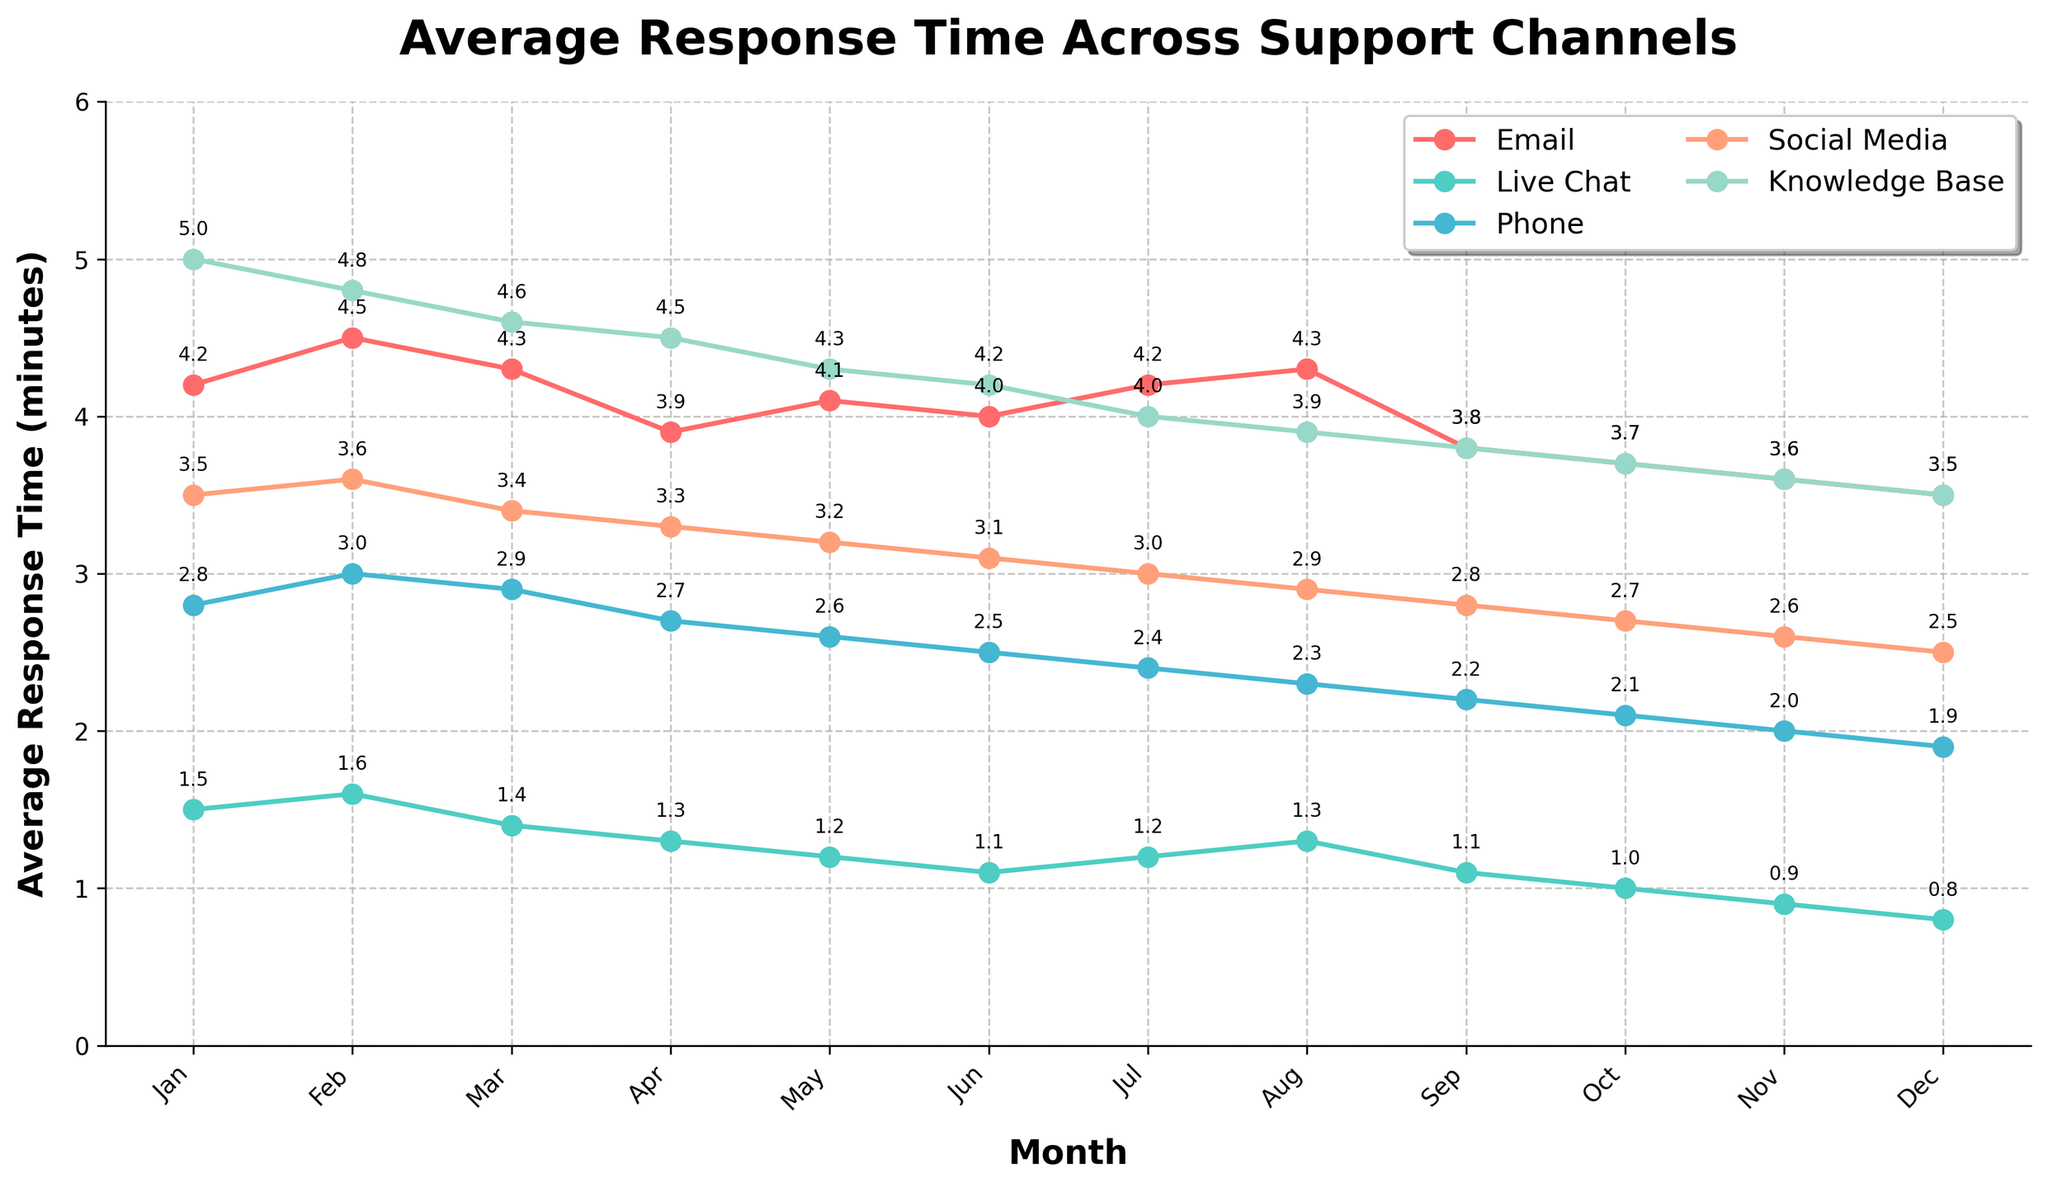What's the channel with the fastest response time in December? Looking at the chart, the line representing Live Chat has the lowest point in December.
Answer: Live Chat Which month shows the highest response time for the Email channel? The chart shows the highest point for the Email line in February.
Answer: February What is the trend in the Phone channel’s response time from January to December? The chart shows a steadily decreasing line for the Phone channel from January to December.
Answer: Decreasing Compare the average response times between Social Media and Knowledge Base in June. Which one is higher? In June, the chart shows that Social Media has an average response time lower than Knowledge Base.
Answer: Knowledge Base What's the difference between the response times of Live Chat and Phone in October? In October, the chart shows that Live Chat has a response time of 1.0 mins and Phone has 2.1 mins. The difference is 2.1 - 1.0 = 1.1 mins.
Answer: 1.1 mins What is the most significant visual change in the Knowledge Base channel over the year? The chart shows a steep decline from January to December for the Knowledge Base channel.
Answer: Steep decline Which channel shows the most consistent average response time throughout the year? From the chart, Live Chat has the most consistent average response time with a smooth downward trend and small fluctuations.
Answer: Live Chat What is the average response time for the Email channel in the first half of the year (Jan-Jun)? The response times for Email from Jan to Jun are 4.2, 4.5, 4.3, 3.9, 4.1, and 4.0. The sum is 24.0, and the average is 24.0 / 6 = 4.0 mins.
Answer: 4.0 mins Which month had the highest average response time among all channels combined? The highest points across all lines in a single month appear in January. Adding the maximum values of all channels in January gives a sum higher than any other month.
Answer: January By how much did the Social Media channel's response time decrease from January to December? The chart shows Social Media's response time at 3.5 mins in January and 2.5 mins in December. The decrease is 3.5 - 2.5 = 1.0 mins.
Answer: 1.0 mins 